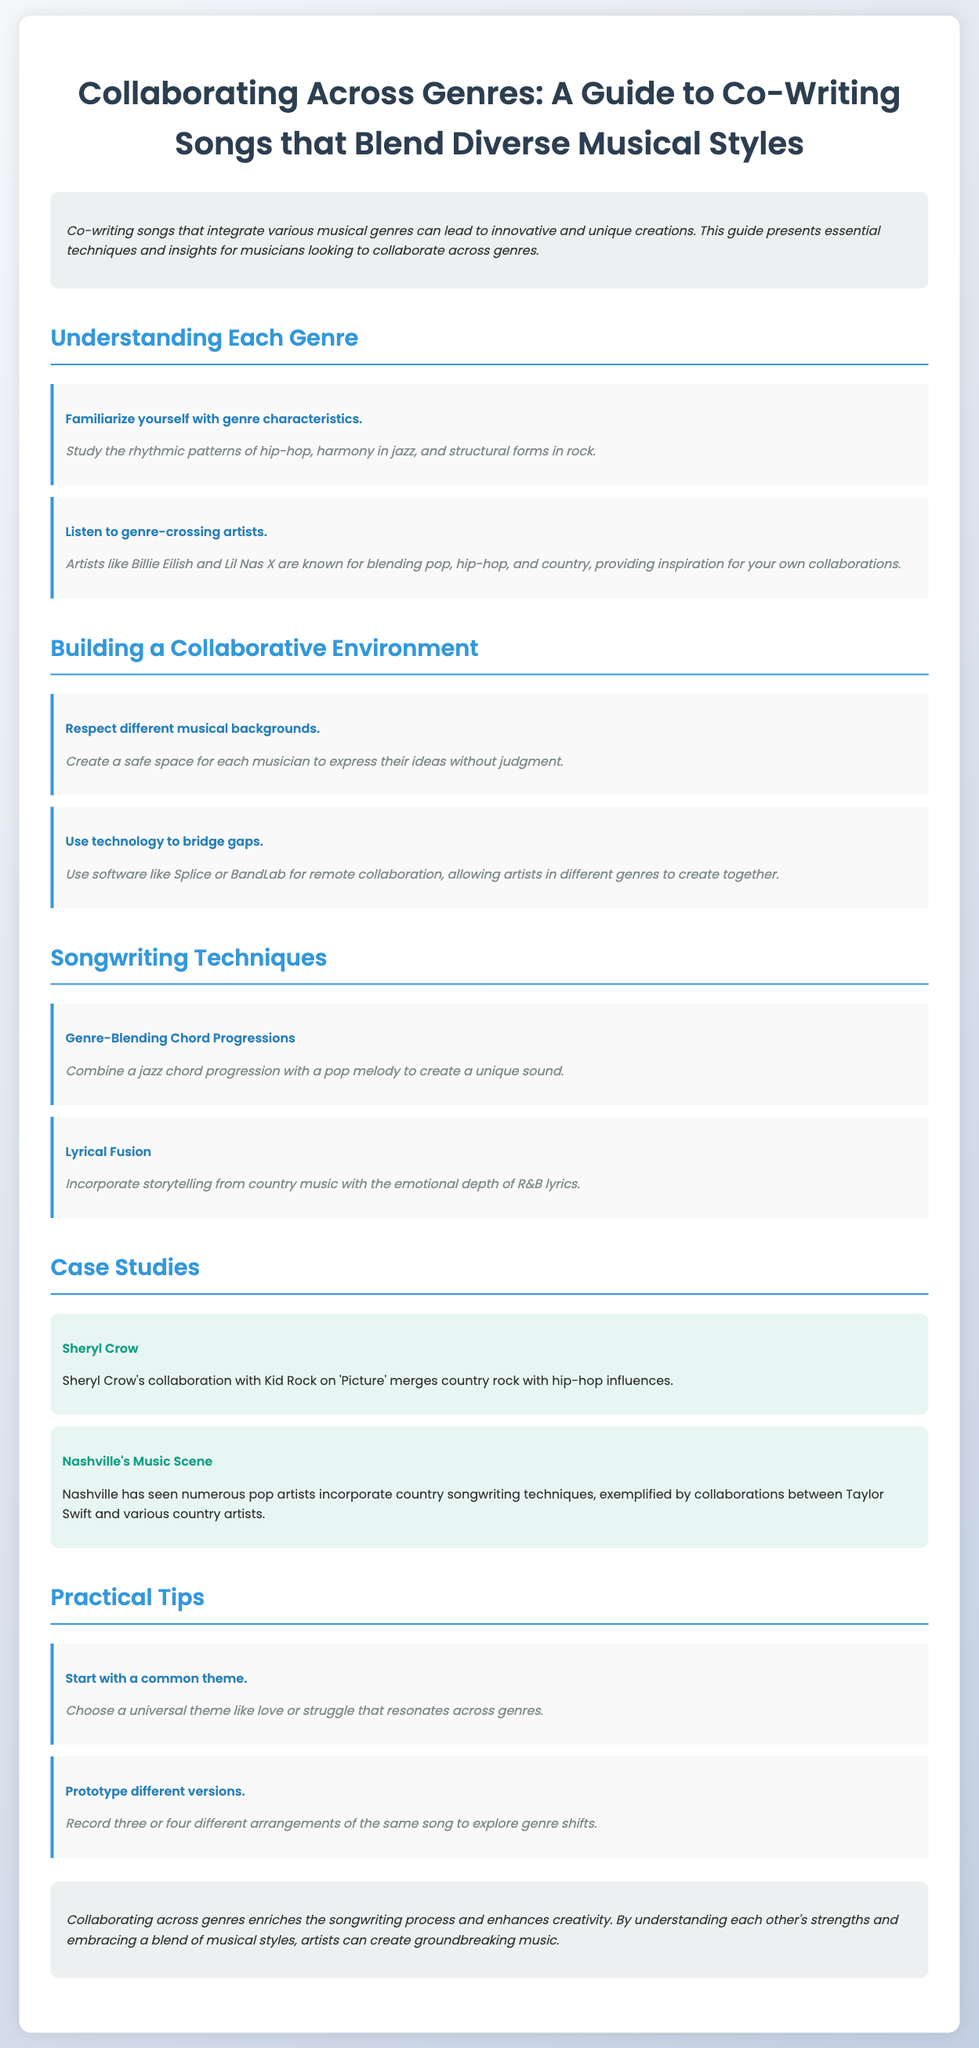what is the title of the guide? The title is listed prominently at the top of the document, indicating the main focus of the content.
Answer: Collaborating Across Genres: A Guide to Co-Writing Songs that Blend Diverse Musical Styles who collaborated with Sheryl Crow on the song 'Picture'? The document provides a specific case study mentioning the artist who collaborated with Sheryl Crow.
Answer: Kid Rock what are two examples of genre-crossing artists? The section mentions specific artists known for blending genres as an inspiration for collaborations.
Answer: Billie Eilish and Lil Nas X what is one technique suggested for songwriting across genres? The document outlines specific techniques for blending musical styles within the songwriting process.
Answer: Genre-Blending Chord Progressions what is a practical tip for starting a collaboration? The guide includes suggestions on how to initiate a collaborative songwriting process effectively.
Answer: Start with a common theme what specific role does technology play in collaboration? The document describes a specific use of technology to support musicians working together across different genres.
Answer: Use technology to bridge gaps which music scene is highlighted for genre blending? The case studies mention a particular city known for its diverse musical collaborations.
Answer: Nashville name one lyrical fusion example provided in the guide. The document illustrates how to combine different lyrical themes to enhance creativity in songwriting.
Answer: Storytelling from country music with the emotional depth of R&B lyrics 